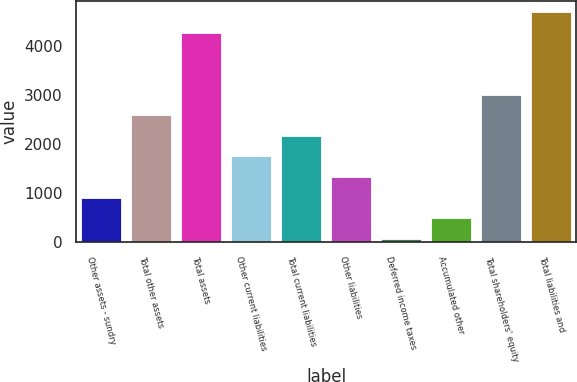Convert chart to OTSL. <chart><loc_0><loc_0><loc_500><loc_500><bar_chart><fcel>Other assets - sundry<fcel>Total other assets<fcel>Total assets<fcel>Other current liabilities<fcel>Total current liabilities<fcel>Other liabilities<fcel>Deferred income taxes<fcel>Accumulated other<fcel>Total shareholders' equity<fcel>Total liabilities and<nl><fcel>906.74<fcel>2586.02<fcel>4265.3<fcel>1746.38<fcel>2166.2<fcel>1326.56<fcel>67.1<fcel>486.92<fcel>3005.84<fcel>4685.12<nl></chart> 